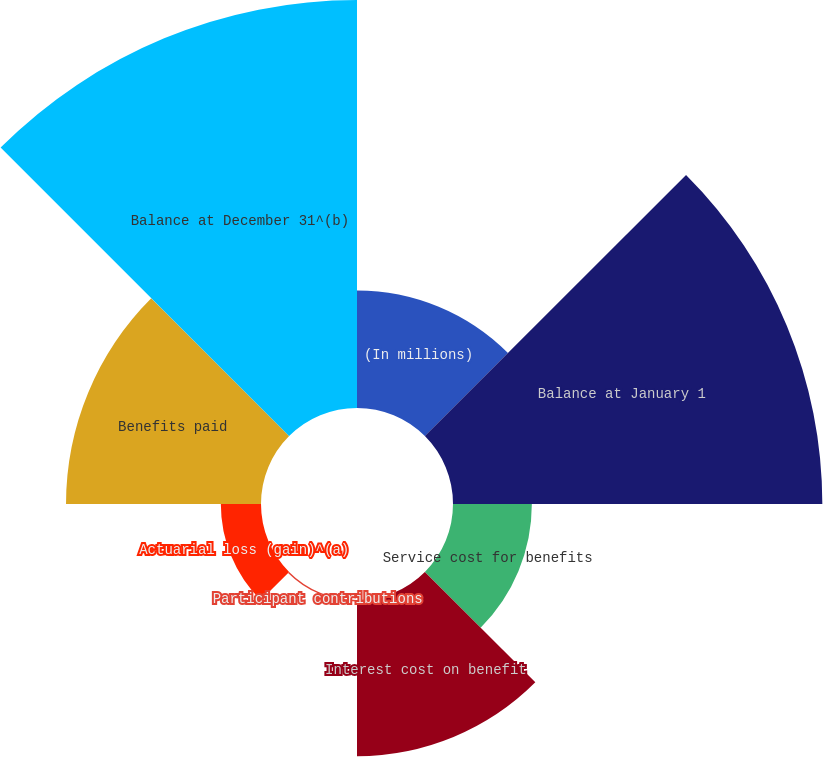<chart> <loc_0><loc_0><loc_500><loc_500><pie_chart><fcel>(In millions)<fcel>Balance at January 1<fcel>Service cost for benefits<fcel>Interest cost on benefit<fcel>Participant contributions<fcel>Actuarial loss (gain)^(a)<fcel>Benefits paid<fcel>Balance at December 31^(b)<nl><fcel>8.6%<fcel>27.03%<fcel>5.77%<fcel>11.43%<fcel>0.11%<fcel>2.94%<fcel>14.27%<fcel>29.86%<nl></chart> 